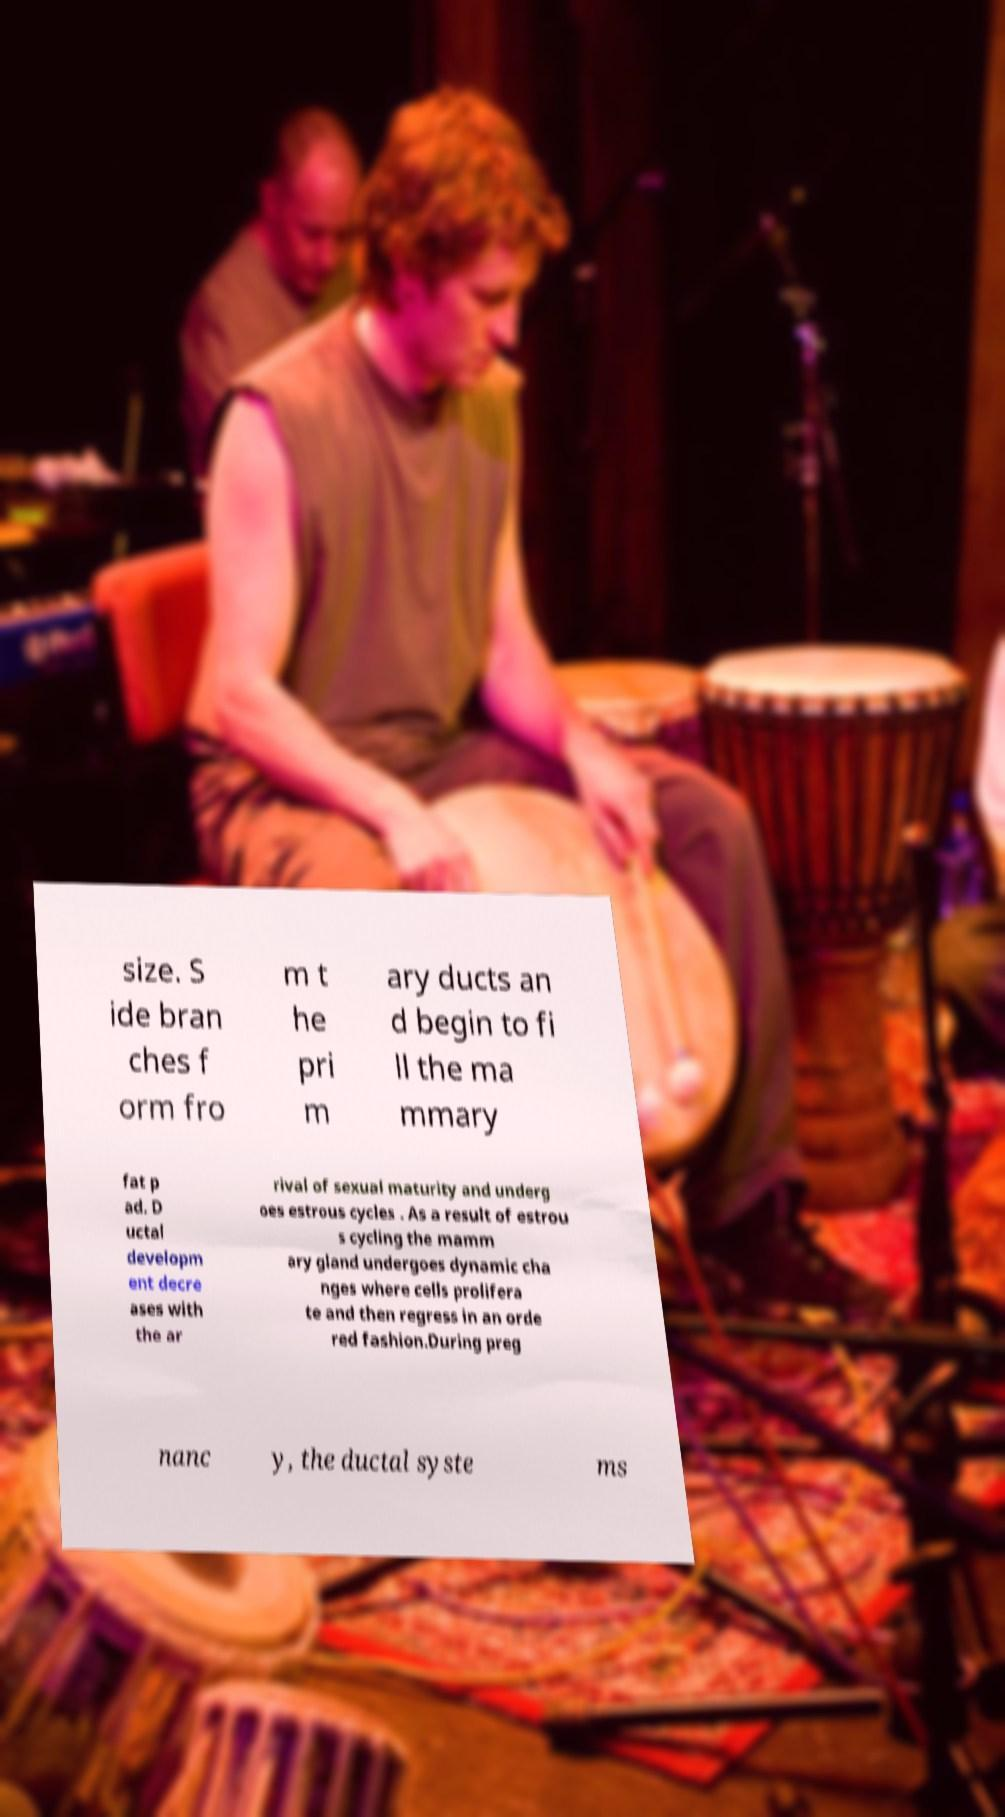For documentation purposes, I need the text within this image transcribed. Could you provide that? size. S ide bran ches f orm fro m t he pri m ary ducts an d begin to fi ll the ma mmary fat p ad. D uctal developm ent decre ases with the ar rival of sexual maturity and underg oes estrous cycles . As a result of estrou s cycling the mamm ary gland undergoes dynamic cha nges where cells prolifera te and then regress in an orde red fashion.During preg nanc y, the ductal syste ms 